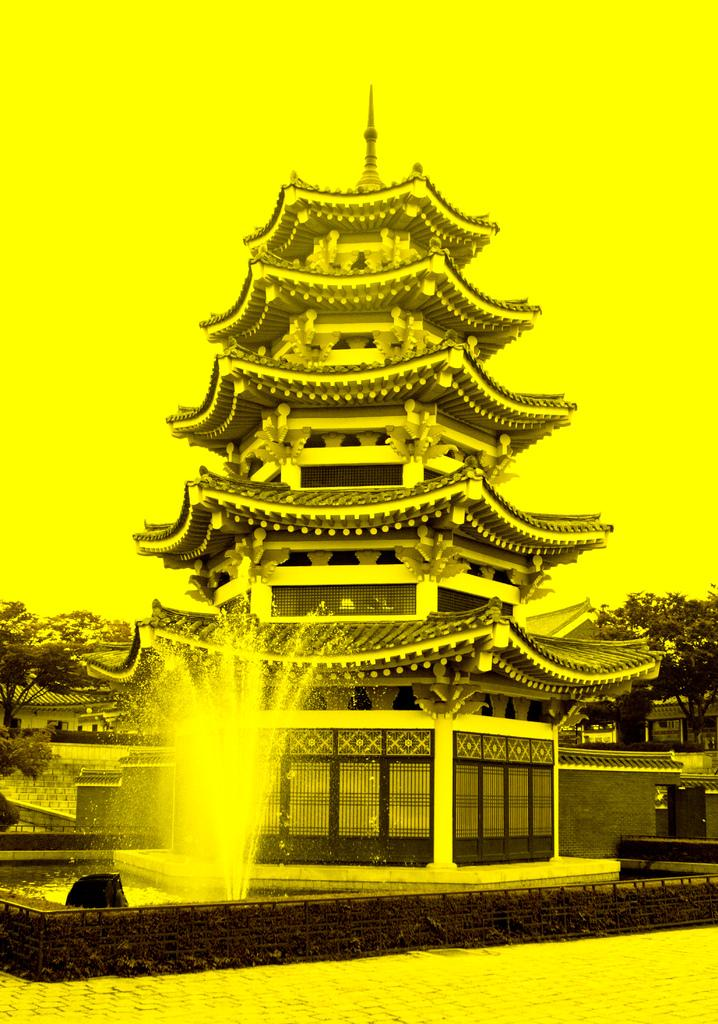What type of image is being described? The image is an edited picture. What can be seen in the image in terms of structures? There is an architecture and a water fountain in the image. What is the purpose of the walkway in the image? The walkway in the image provides a path for people to walk on. What can be seen in the background of the image? The background of the image includes houses, trees, and the sky. How many snakes are slithering on the walkway in the image? There are no snakes present in the image; the walkway is clear. What color is the rose on the architecture in the image? There is no rose present on the architecture in the image. 